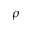<formula> <loc_0><loc_0><loc_500><loc_500>\rho</formula> 